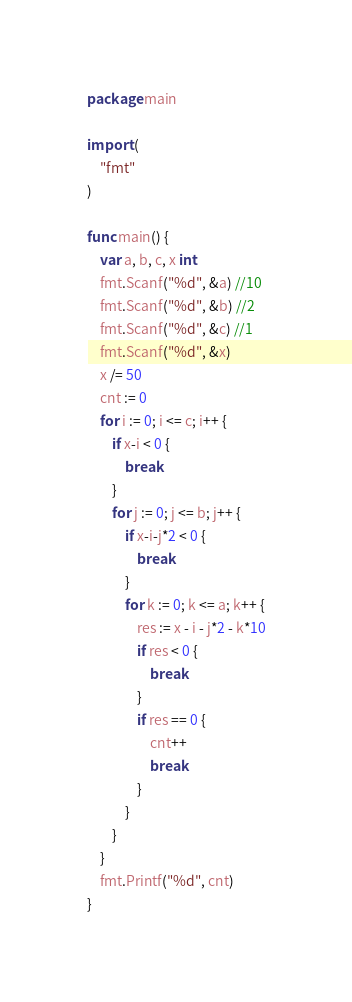<code> <loc_0><loc_0><loc_500><loc_500><_Go_>package main

import (
	"fmt"
)

func main() {
	var a, b, c, x int
	fmt.Scanf("%d", &a) //10
	fmt.Scanf("%d", &b) //2
	fmt.Scanf("%d", &c) //1
	fmt.Scanf("%d", &x)
	x /= 50
	cnt := 0
	for i := 0; i <= c; i++ {
		if x-i < 0 {
			break
		}
		for j := 0; j <= b; j++ {
			if x-i-j*2 < 0 {
				break
			}
			for k := 0; k <= a; k++ {
				res := x - i - j*2 - k*10
				if res < 0 {
					break
				}
				if res == 0 {
					cnt++
					break
				}
			}
		}
	}
	fmt.Printf("%d", cnt)
}
</code> 